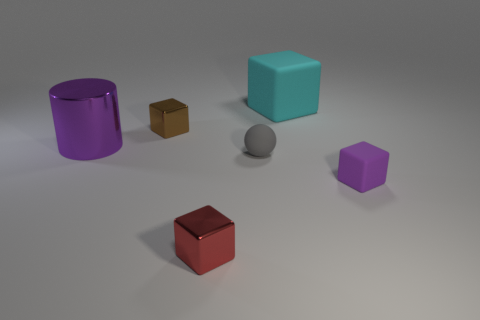There is another tiny thing that is the same material as the brown thing; what is its color?
Provide a short and direct response. Red. What is the color of the large object that is to the left of the shiny object in front of the purple object in front of the large metal cylinder?
Your answer should be compact. Purple. How many spheres are either big purple metallic things or rubber things?
Your response must be concise. 1. There is a large cylinder that is the same color as the small matte cube; what is its material?
Provide a short and direct response. Metal. Does the cylinder have the same color as the rubber block that is in front of the big cylinder?
Your answer should be very brief. Yes. What is the color of the tiny matte cube?
Provide a succinct answer. Purple. How many things are metallic cubes or tiny gray things?
Provide a succinct answer. 3. There is a ball that is the same size as the purple rubber cube; what material is it?
Keep it short and to the point. Rubber. How big is the matte cube behind the small purple block?
Give a very brief answer. Large. What is the small purple thing made of?
Offer a terse response. Rubber. 